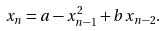Convert formula to latex. <formula><loc_0><loc_0><loc_500><loc_500>x _ { n } = a - x _ { n - 1 } ^ { 2 } + b x _ { n - 2 } .</formula> 